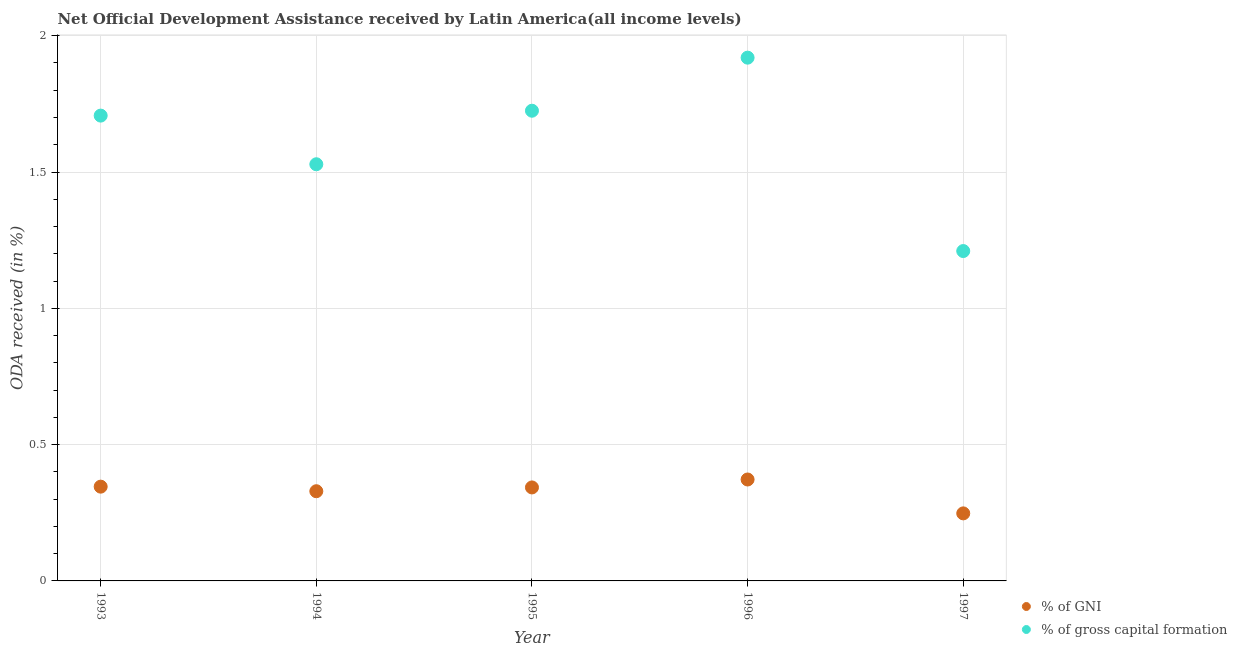How many different coloured dotlines are there?
Provide a short and direct response. 2. What is the oda received as percentage of gross capital formation in 1997?
Give a very brief answer. 1.21. Across all years, what is the maximum oda received as percentage of gni?
Offer a very short reply. 0.37. Across all years, what is the minimum oda received as percentage of gross capital formation?
Keep it short and to the point. 1.21. What is the total oda received as percentage of gross capital formation in the graph?
Your answer should be compact. 8.09. What is the difference between the oda received as percentage of gross capital formation in 1993 and that in 1995?
Provide a succinct answer. -0.02. What is the difference between the oda received as percentage of gni in 1996 and the oda received as percentage of gross capital formation in 1995?
Keep it short and to the point. -1.35. What is the average oda received as percentage of gross capital formation per year?
Provide a short and direct response. 1.62. In the year 1996, what is the difference between the oda received as percentage of gross capital formation and oda received as percentage of gni?
Your answer should be compact. 1.55. In how many years, is the oda received as percentage of gross capital formation greater than 1.2 %?
Your response must be concise. 5. What is the ratio of the oda received as percentage of gni in 1993 to that in 1994?
Your response must be concise. 1.05. What is the difference between the highest and the second highest oda received as percentage of gni?
Provide a succinct answer. 0.03. What is the difference between the highest and the lowest oda received as percentage of gross capital formation?
Give a very brief answer. 0.71. Is the sum of the oda received as percentage of gross capital formation in 1996 and 1997 greater than the maximum oda received as percentage of gni across all years?
Make the answer very short. Yes. Does the oda received as percentage of gross capital formation monotonically increase over the years?
Make the answer very short. No. Is the oda received as percentage of gni strictly greater than the oda received as percentage of gross capital formation over the years?
Your answer should be compact. No. How many dotlines are there?
Your response must be concise. 2. What is the difference between two consecutive major ticks on the Y-axis?
Make the answer very short. 0.5. Does the graph contain any zero values?
Give a very brief answer. No. Where does the legend appear in the graph?
Make the answer very short. Bottom right. How many legend labels are there?
Give a very brief answer. 2. What is the title of the graph?
Your answer should be compact. Net Official Development Assistance received by Latin America(all income levels). Does "GDP per capita" appear as one of the legend labels in the graph?
Offer a terse response. No. What is the label or title of the Y-axis?
Give a very brief answer. ODA received (in %). What is the ODA received (in %) of % of GNI in 1993?
Make the answer very short. 0.35. What is the ODA received (in %) in % of gross capital formation in 1993?
Ensure brevity in your answer.  1.71. What is the ODA received (in %) of % of GNI in 1994?
Your answer should be compact. 0.33. What is the ODA received (in %) in % of gross capital formation in 1994?
Give a very brief answer. 1.53. What is the ODA received (in %) of % of GNI in 1995?
Ensure brevity in your answer.  0.34. What is the ODA received (in %) in % of gross capital formation in 1995?
Make the answer very short. 1.72. What is the ODA received (in %) of % of GNI in 1996?
Your response must be concise. 0.37. What is the ODA received (in %) of % of gross capital formation in 1996?
Offer a very short reply. 1.92. What is the ODA received (in %) in % of GNI in 1997?
Your answer should be very brief. 0.25. What is the ODA received (in %) of % of gross capital formation in 1997?
Your response must be concise. 1.21. Across all years, what is the maximum ODA received (in %) of % of GNI?
Your answer should be very brief. 0.37. Across all years, what is the maximum ODA received (in %) in % of gross capital formation?
Your response must be concise. 1.92. Across all years, what is the minimum ODA received (in %) of % of GNI?
Your answer should be compact. 0.25. Across all years, what is the minimum ODA received (in %) in % of gross capital formation?
Ensure brevity in your answer.  1.21. What is the total ODA received (in %) of % of GNI in the graph?
Keep it short and to the point. 1.64. What is the total ODA received (in %) in % of gross capital formation in the graph?
Keep it short and to the point. 8.09. What is the difference between the ODA received (in %) of % of GNI in 1993 and that in 1994?
Your answer should be compact. 0.02. What is the difference between the ODA received (in %) of % of gross capital formation in 1993 and that in 1994?
Offer a terse response. 0.18. What is the difference between the ODA received (in %) in % of GNI in 1993 and that in 1995?
Give a very brief answer. 0. What is the difference between the ODA received (in %) in % of gross capital formation in 1993 and that in 1995?
Keep it short and to the point. -0.02. What is the difference between the ODA received (in %) in % of GNI in 1993 and that in 1996?
Give a very brief answer. -0.03. What is the difference between the ODA received (in %) of % of gross capital formation in 1993 and that in 1996?
Keep it short and to the point. -0.21. What is the difference between the ODA received (in %) in % of GNI in 1993 and that in 1997?
Your answer should be compact. 0.1. What is the difference between the ODA received (in %) in % of gross capital formation in 1993 and that in 1997?
Your answer should be compact. 0.5. What is the difference between the ODA received (in %) in % of GNI in 1994 and that in 1995?
Make the answer very short. -0.01. What is the difference between the ODA received (in %) in % of gross capital formation in 1994 and that in 1995?
Provide a succinct answer. -0.2. What is the difference between the ODA received (in %) in % of GNI in 1994 and that in 1996?
Give a very brief answer. -0.04. What is the difference between the ODA received (in %) in % of gross capital formation in 1994 and that in 1996?
Your answer should be compact. -0.39. What is the difference between the ODA received (in %) of % of GNI in 1994 and that in 1997?
Keep it short and to the point. 0.08. What is the difference between the ODA received (in %) in % of gross capital formation in 1994 and that in 1997?
Your answer should be compact. 0.32. What is the difference between the ODA received (in %) in % of GNI in 1995 and that in 1996?
Provide a succinct answer. -0.03. What is the difference between the ODA received (in %) of % of gross capital formation in 1995 and that in 1996?
Provide a succinct answer. -0.19. What is the difference between the ODA received (in %) of % of GNI in 1995 and that in 1997?
Keep it short and to the point. 0.1. What is the difference between the ODA received (in %) in % of gross capital formation in 1995 and that in 1997?
Provide a short and direct response. 0.51. What is the difference between the ODA received (in %) of % of GNI in 1996 and that in 1997?
Your answer should be compact. 0.12. What is the difference between the ODA received (in %) in % of gross capital formation in 1996 and that in 1997?
Your response must be concise. 0.71. What is the difference between the ODA received (in %) in % of GNI in 1993 and the ODA received (in %) in % of gross capital formation in 1994?
Your answer should be very brief. -1.18. What is the difference between the ODA received (in %) in % of GNI in 1993 and the ODA received (in %) in % of gross capital formation in 1995?
Keep it short and to the point. -1.38. What is the difference between the ODA received (in %) of % of GNI in 1993 and the ODA received (in %) of % of gross capital formation in 1996?
Offer a terse response. -1.57. What is the difference between the ODA received (in %) of % of GNI in 1993 and the ODA received (in %) of % of gross capital formation in 1997?
Provide a short and direct response. -0.86. What is the difference between the ODA received (in %) in % of GNI in 1994 and the ODA received (in %) in % of gross capital formation in 1995?
Give a very brief answer. -1.4. What is the difference between the ODA received (in %) of % of GNI in 1994 and the ODA received (in %) of % of gross capital formation in 1996?
Provide a short and direct response. -1.59. What is the difference between the ODA received (in %) in % of GNI in 1994 and the ODA received (in %) in % of gross capital formation in 1997?
Provide a succinct answer. -0.88. What is the difference between the ODA received (in %) of % of GNI in 1995 and the ODA received (in %) of % of gross capital formation in 1996?
Ensure brevity in your answer.  -1.58. What is the difference between the ODA received (in %) in % of GNI in 1995 and the ODA received (in %) in % of gross capital formation in 1997?
Your answer should be very brief. -0.87. What is the difference between the ODA received (in %) in % of GNI in 1996 and the ODA received (in %) in % of gross capital formation in 1997?
Provide a succinct answer. -0.84. What is the average ODA received (in %) in % of GNI per year?
Your response must be concise. 0.33. What is the average ODA received (in %) in % of gross capital formation per year?
Your answer should be compact. 1.62. In the year 1993, what is the difference between the ODA received (in %) in % of GNI and ODA received (in %) in % of gross capital formation?
Ensure brevity in your answer.  -1.36. In the year 1994, what is the difference between the ODA received (in %) in % of GNI and ODA received (in %) in % of gross capital formation?
Provide a succinct answer. -1.2. In the year 1995, what is the difference between the ODA received (in %) of % of GNI and ODA received (in %) of % of gross capital formation?
Offer a very short reply. -1.38. In the year 1996, what is the difference between the ODA received (in %) in % of GNI and ODA received (in %) in % of gross capital formation?
Provide a short and direct response. -1.55. In the year 1997, what is the difference between the ODA received (in %) of % of GNI and ODA received (in %) of % of gross capital formation?
Offer a terse response. -0.96. What is the ratio of the ODA received (in %) of % of GNI in 1993 to that in 1994?
Keep it short and to the point. 1.05. What is the ratio of the ODA received (in %) in % of gross capital formation in 1993 to that in 1994?
Offer a terse response. 1.12. What is the ratio of the ODA received (in %) of % of GNI in 1993 to that in 1995?
Your answer should be compact. 1.01. What is the ratio of the ODA received (in %) in % of GNI in 1993 to that in 1996?
Provide a succinct answer. 0.93. What is the ratio of the ODA received (in %) of % of gross capital formation in 1993 to that in 1996?
Keep it short and to the point. 0.89. What is the ratio of the ODA received (in %) in % of GNI in 1993 to that in 1997?
Provide a succinct answer. 1.4. What is the ratio of the ODA received (in %) in % of gross capital formation in 1993 to that in 1997?
Provide a short and direct response. 1.41. What is the ratio of the ODA received (in %) in % of GNI in 1994 to that in 1995?
Your answer should be compact. 0.96. What is the ratio of the ODA received (in %) of % of gross capital formation in 1994 to that in 1995?
Ensure brevity in your answer.  0.89. What is the ratio of the ODA received (in %) in % of GNI in 1994 to that in 1996?
Your answer should be compact. 0.88. What is the ratio of the ODA received (in %) in % of gross capital formation in 1994 to that in 1996?
Your answer should be very brief. 0.8. What is the ratio of the ODA received (in %) in % of GNI in 1994 to that in 1997?
Give a very brief answer. 1.33. What is the ratio of the ODA received (in %) of % of gross capital formation in 1994 to that in 1997?
Your answer should be compact. 1.26. What is the ratio of the ODA received (in %) in % of GNI in 1995 to that in 1996?
Provide a short and direct response. 0.92. What is the ratio of the ODA received (in %) in % of gross capital formation in 1995 to that in 1996?
Your response must be concise. 0.9. What is the ratio of the ODA received (in %) in % of GNI in 1995 to that in 1997?
Make the answer very short. 1.38. What is the ratio of the ODA received (in %) of % of gross capital formation in 1995 to that in 1997?
Keep it short and to the point. 1.43. What is the ratio of the ODA received (in %) in % of GNI in 1996 to that in 1997?
Your response must be concise. 1.5. What is the ratio of the ODA received (in %) of % of gross capital formation in 1996 to that in 1997?
Your response must be concise. 1.59. What is the difference between the highest and the second highest ODA received (in %) of % of GNI?
Provide a short and direct response. 0.03. What is the difference between the highest and the second highest ODA received (in %) of % of gross capital formation?
Ensure brevity in your answer.  0.19. What is the difference between the highest and the lowest ODA received (in %) in % of GNI?
Your response must be concise. 0.12. What is the difference between the highest and the lowest ODA received (in %) in % of gross capital formation?
Your response must be concise. 0.71. 